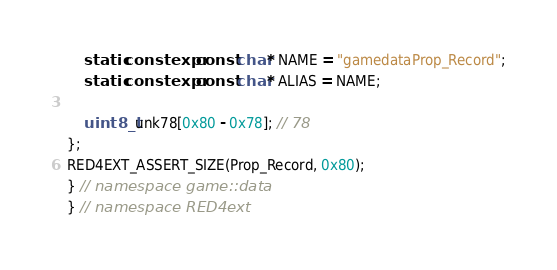Convert code to text. <code><loc_0><loc_0><loc_500><loc_500><_C++_>    static constexpr const char* NAME = "gamedataProp_Record";
    static constexpr const char* ALIAS = NAME;

    uint8_t unk78[0x80 - 0x78]; // 78
};
RED4EXT_ASSERT_SIZE(Prop_Record, 0x80);
} // namespace game::data
} // namespace RED4ext
</code> 